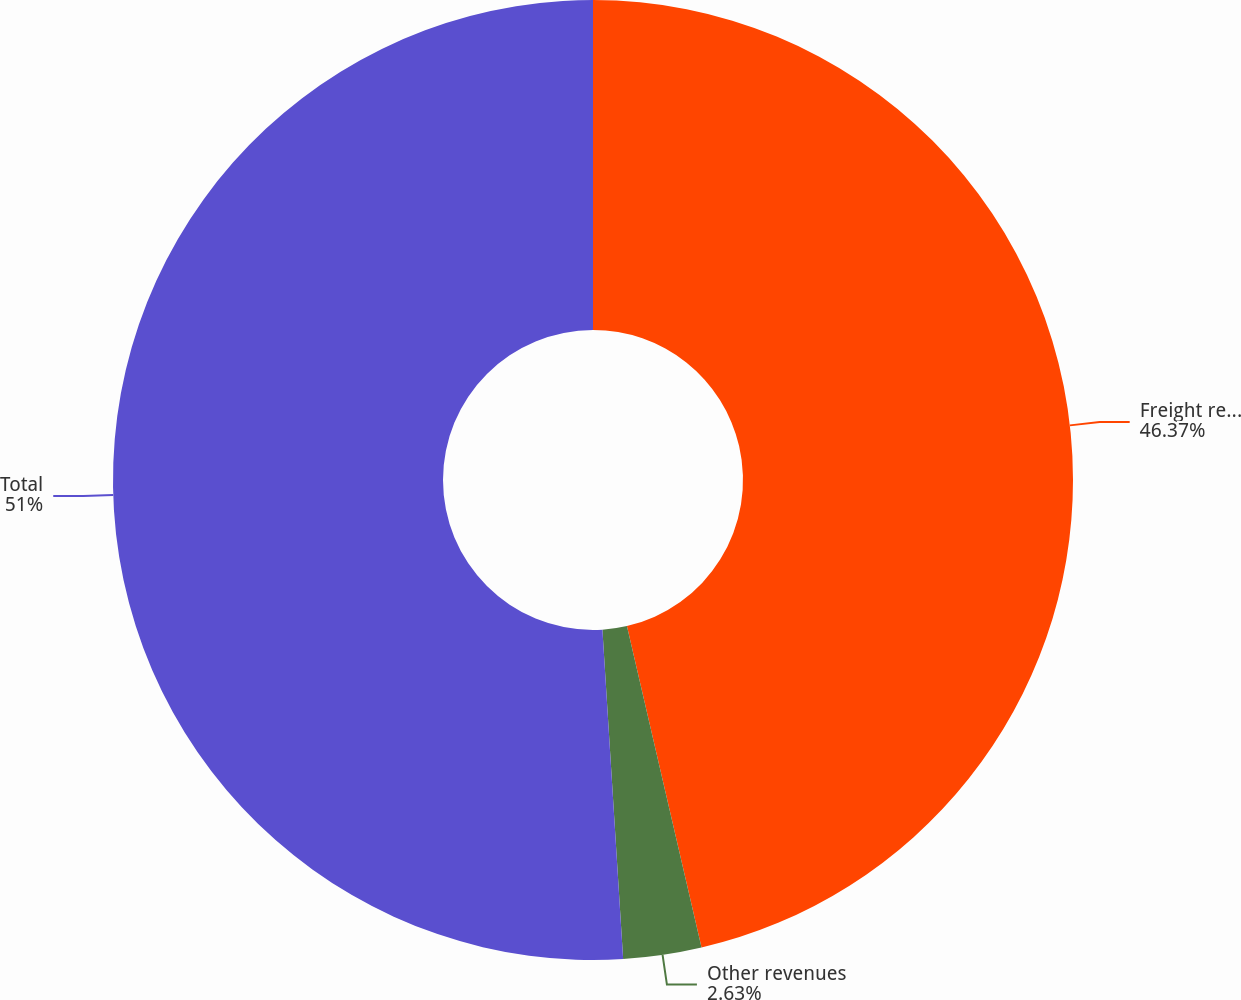<chart> <loc_0><loc_0><loc_500><loc_500><pie_chart><fcel>Freight revenues<fcel>Other revenues<fcel>Total<nl><fcel>46.37%<fcel>2.63%<fcel>51.0%<nl></chart> 